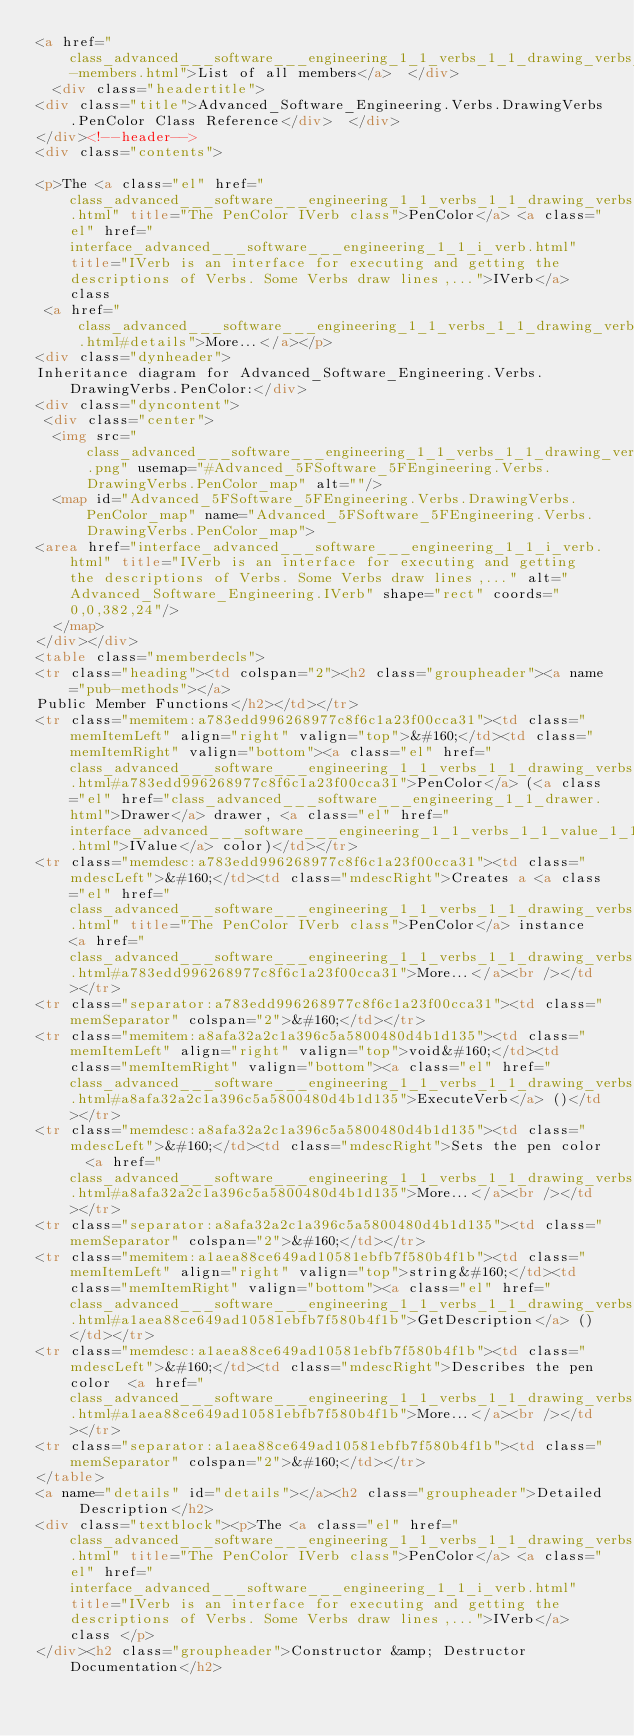<code> <loc_0><loc_0><loc_500><loc_500><_HTML_><a href="class_advanced___software___engineering_1_1_verbs_1_1_drawing_verbs_1_1_pen_color-members.html">List of all members</a>  </div>
  <div class="headertitle">
<div class="title">Advanced_Software_Engineering.Verbs.DrawingVerbs.PenColor Class Reference</div>  </div>
</div><!--header-->
<div class="contents">

<p>The <a class="el" href="class_advanced___software___engineering_1_1_verbs_1_1_drawing_verbs_1_1_pen_color.html" title="The PenColor IVerb class">PenColor</a> <a class="el" href="interface_advanced___software___engineering_1_1_i_verb.html" title="IVerb is an interface for executing and getting the descriptions of Verbs. Some Verbs draw lines,...">IVerb</a> class  
 <a href="class_advanced___software___engineering_1_1_verbs_1_1_drawing_verbs_1_1_pen_color.html#details">More...</a></p>
<div class="dynheader">
Inheritance diagram for Advanced_Software_Engineering.Verbs.DrawingVerbs.PenColor:</div>
<div class="dyncontent">
 <div class="center">
  <img src="class_advanced___software___engineering_1_1_verbs_1_1_drawing_verbs_1_1_pen_color.png" usemap="#Advanced_5FSoftware_5FEngineering.Verbs.DrawingVerbs.PenColor_map" alt=""/>
  <map id="Advanced_5FSoftware_5FEngineering.Verbs.DrawingVerbs.PenColor_map" name="Advanced_5FSoftware_5FEngineering.Verbs.DrawingVerbs.PenColor_map">
<area href="interface_advanced___software___engineering_1_1_i_verb.html" title="IVerb is an interface for executing and getting the descriptions of Verbs. Some Verbs draw lines,..." alt="Advanced_Software_Engineering.IVerb" shape="rect" coords="0,0,382,24"/>
  </map>
</div></div>
<table class="memberdecls">
<tr class="heading"><td colspan="2"><h2 class="groupheader"><a name="pub-methods"></a>
Public Member Functions</h2></td></tr>
<tr class="memitem:a783edd996268977c8f6c1a23f00cca31"><td class="memItemLeft" align="right" valign="top">&#160;</td><td class="memItemRight" valign="bottom"><a class="el" href="class_advanced___software___engineering_1_1_verbs_1_1_drawing_verbs_1_1_pen_color.html#a783edd996268977c8f6c1a23f00cca31">PenColor</a> (<a class="el" href="class_advanced___software___engineering_1_1_drawer.html">Drawer</a> drawer, <a class="el" href="interface_advanced___software___engineering_1_1_verbs_1_1_value_1_1_i_value.html">IValue</a> color)</td></tr>
<tr class="memdesc:a783edd996268977c8f6c1a23f00cca31"><td class="mdescLeft">&#160;</td><td class="mdescRight">Creates a <a class="el" href="class_advanced___software___engineering_1_1_verbs_1_1_drawing_verbs_1_1_pen_color.html" title="The PenColor IVerb class">PenColor</a> instance  <a href="class_advanced___software___engineering_1_1_verbs_1_1_drawing_verbs_1_1_pen_color.html#a783edd996268977c8f6c1a23f00cca31">More...</a><br /></td></tr>
<tr class="separator:a783edd996268977c8f6c1a23f00cca31"><td class="memSeparator" colspan="2">&#160;</td></tr>
<tr class="memitem:a8afa32a2c1a396c5a5800480d4b1d135"><td class="memItemLeft" align="right" valign="top">void&#160;</td><td class="memItemRight" valign="bottom"><a class="el" href="class_advanced___software___engineering_1_1_verbs_1_1_drawing_verbs_1_1_pen_color.html#a8afa32a2c1a396c5a5800480d4b1d135">ExecuteVerb</a> ()</td></tr>
<tr class="memdesc:a8afa32a2c1a396c5a5800480d4b1d135"><td class="mdescLeft">&#160;</td><td class="mdescRight">Sets the pen color  <a href="class_advanced___software___engineering_1_1_verbs_1_1_drawing_verbs_1_1_pen_color.html#a8afa32a2c1a396c5a5800480d4b1d135">More...</a><br /></td></tr>
<tr class="separator:a8afa32a2c1a396c5a5800480d4b1d135"><td class="memSeparator" colspan="2">&#160;</td></tr>
<tr class="memitem:a1aea88ce649ad10581ebfb7f580b4f1b"><td class="memItemLeft" align="right" valign="top">string&#160;</td><td class="memItemRight" valign="bottom"><a class="el" href="class_advanced___software___engineering_1_1_verbs_1_1_drawing_verbs_1_1_pen_color.html#a1aea88ce649ad10581ebfb7f580b4f1b">GetDescription</a> ()</td></tr>
<tr class="memdesc:a1aea88ce649ad10581ebfb7f580b4f1b"><td class="mdescLeft">&#160;</td><td class="mdescRight">Describes the pen color  <a href="class_advanced___software___engineering_1_1_verbs_1_1_drawing_verbs_1_1_pen_color.html#a1aea88ce649ad10581ebfb7f580b4f1b">More...</a><br /></td></tr>
<tr class="separator:a1aea88ce649ad10581ebfb7f580b4f1b"><td class="memSeparator" colspan="2">&#160;</td></tr>
</table>
<a name="details" id="details"></a><h2 class="groupheader">Detailed Description</h2>
<div class="textblock"><p>The <a class="el" href="class_advanced___software___engineering_1_1_verbs_1_1_drawing_verbs_1_1_pen_color.html" title="The PenColor IVerb class">PenColor</a> <a class="el" href="interface_advanced___software___engineering_1_1_i_verb.html" title="IVerb is an interface for executing and getting the descriptions of Verbs. Some Verbs draw lines,...">IVerb</a> class </p>
</div><h2 class="groupheader">Constructor &amp; Destructor Documentation</h2></code> 